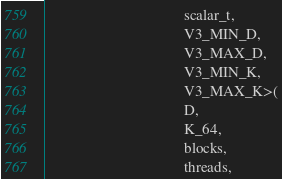<code> <loc_0><loc_0><loc_500><loc_500><_Cuda_>                                     scalar_t,
                                     V3_MIN_D,
                                     V3_MAX_D,
                                     V3_MIN_K,
                                     V3_MAX_K>(
                                     D,
                                     K_64,
                                     blocks,
                                     threads,</code> 